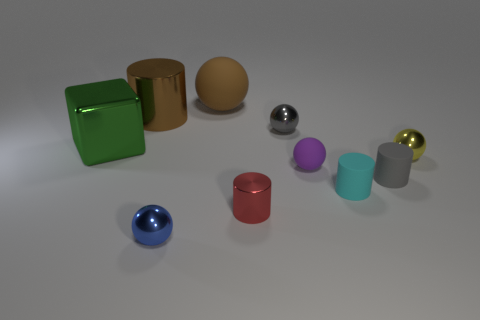There is a big object that is to the left of the tiny blue object and behind the small gray metal sphere; what shape is it?
Your answer should be compact. Cylinder. What number of things are small metal things to the left of the brown rubber sphere or matte objects in front of the purple matte object?
Offer a very short reply. 3. Is the number of cyan cylinders that are on the left side of the big green cube the same as the number of small purple matte objects that are behind the small yellow sphere?
Provide a short and direct response. Yes. There is a brown thing that is to the right of the shiny sphere that is left of the large brown ball; what is its shape?
Ensure brevity in your answer.  Sphere. Is there a blue object of the same shape as the brown matte object?
Make the answer very short. Yes. How many red rubber cylinders are there?
Offer a very short reply. 0. Do the gray thing that is left of the small gray rubber object and the small blue thing have the same material?
Make the answer very short. Yes. Is there a gray object of the same size as the brown cylinder?
Provide a succinct answer. No. There is a gray matte thing; is its shape the same as the small cyan matte object right of the tiny metal cylinder?
Your response must be concise. Yes. Is there a large brown matte sphere to the right of the tiny ball that is in front of the tiny gray object that is in front of the green cube?
Offer a very short reply. Yes. 